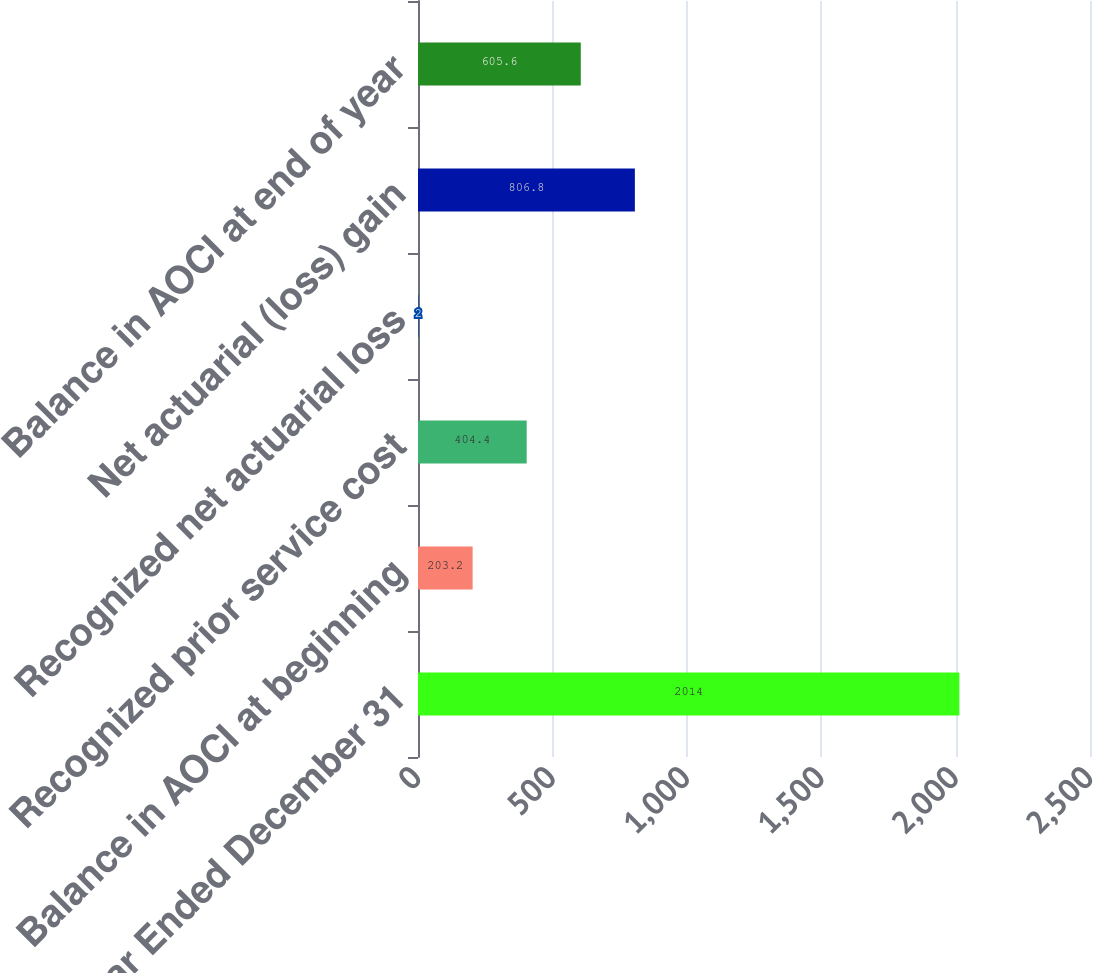<chart> <loc_0><loc_0><loc_500><loc_500><bar_chart><fcel>Year Ended December 31<fcel>Balance in AOCI at beginning<fcel>Recognized prior service cost<fcel>Recognized net actuarial loss<fcel>Net actuarial (loss) gain<fcel>Balance in AOCI at end of year<nl><fcel>2014<fcel>203.2<fcel>404.4<fcel>2<fcel>806.8<fcel>605.6<nl></chart> 